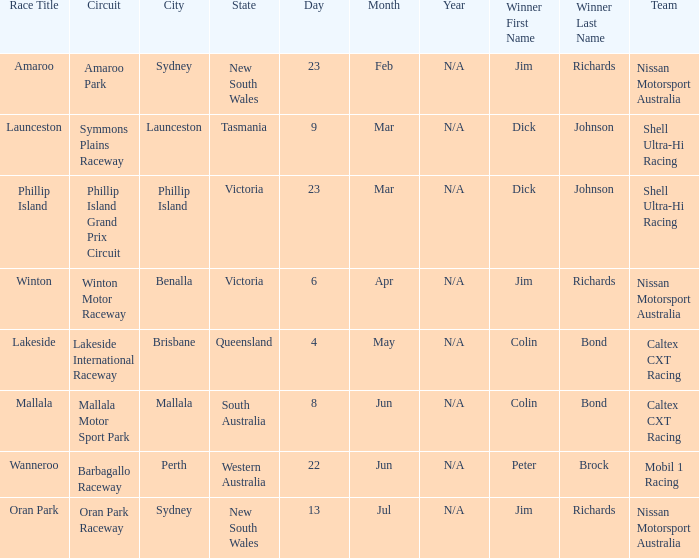Name the team for launceston Shell Ultra-Hi Racing. 